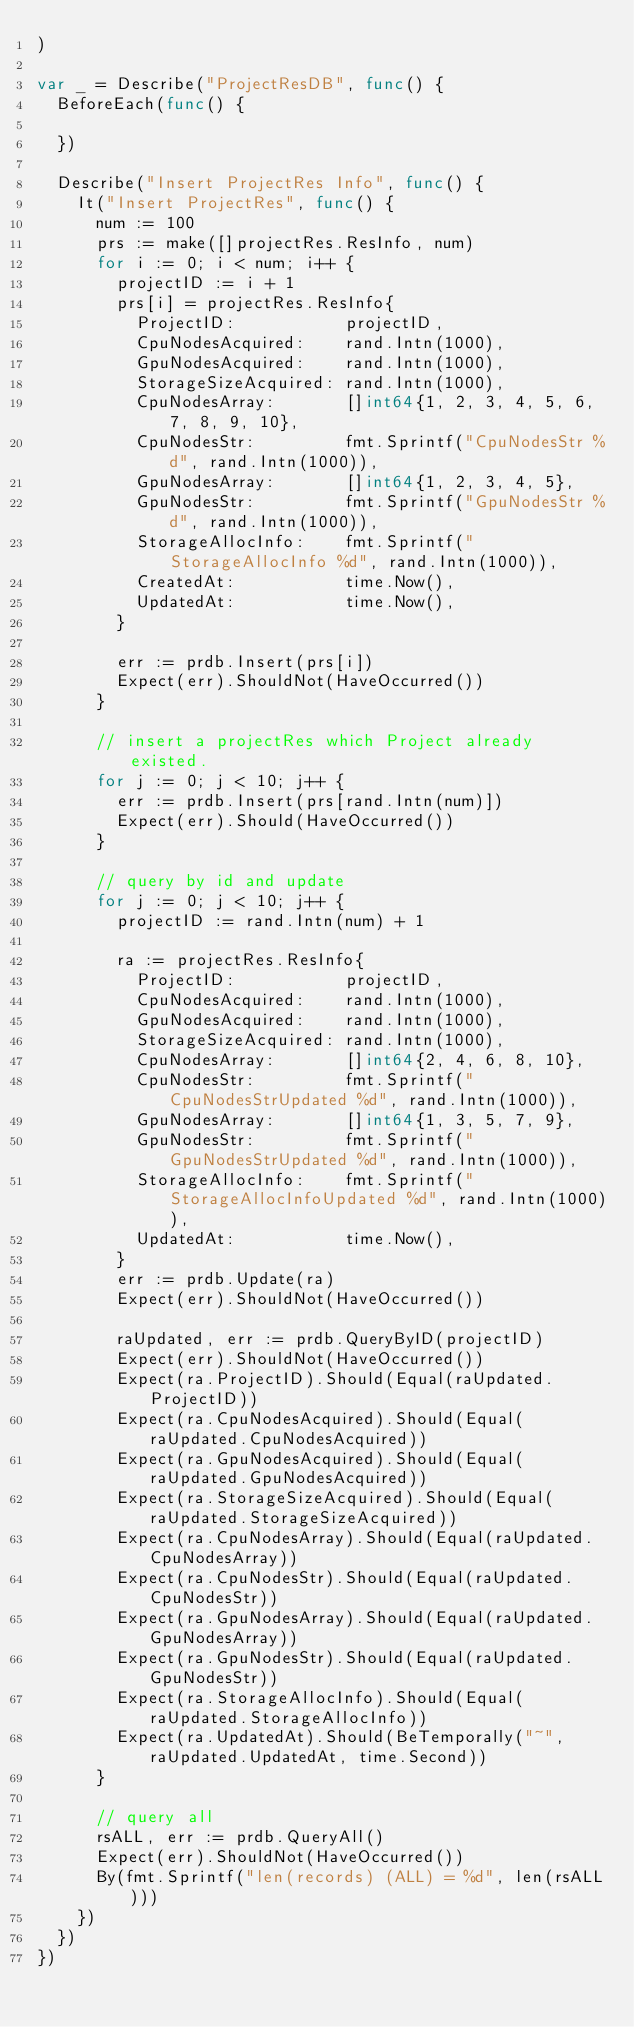<code> <loc_0><loc_0><loc_500><loc_500><_Go_>)

var _ = Describe("ProjectResDB", func() {
	BeforeEach(func() {

	})

	Describe("Insert ProjectRes Info", func() {
		It("Insert ProjectRes", func() {
			num := 100
			prs := make([]projectRes.ResInfo, num)
			for i := 0; i < num; i++ {
				projectID := i + 1
				prs[i] = projectRes.ResInfo{
					ProjectID:           projectID,
					CpuNodesAcquired:    rand.Intn(1000),
					GpuNodesAcquired:    rand.Intn(1000),
					StorageSizeAcquired: rand.Intn(1000),
					CpuNodesArray:       []int64{1, 2, 3, 4, 5, 6, 7, 8, 9, 10},
					CpuNodesStr:         fmt.Sprintf("CpuNodesStr %d", rand.Intn(1000)),
					GpuNodesArray:       []int64{1, 2, 3, 4, 5},
					GpuNodesStr:         fmt.Sprintf("GpuNodesStr %d", rand.Intn(1000)),
					StorageAllocInfo:    fmt.Sprintf("StorageAllocInfo %d", rand.Intn(1000)),
					CreatedAt:           time.Now(),
					UpdatedAt:           time.Now(),
				}

				err := prdb.Insert(prs[i])
				Expect(err).ShouldNot(HaveOccurred())
			}

			// insert a projectRes which Project already existed.
			for j := 0; j < 10; j++ {
				err := prdb.Insert(prs[rand.Intn(num)])
				Expect(err).Should(HaveOccurred())
			}

			// query by id and update
			for j := 0; j < 10; j++ {
				projectID := rand.Intn(num) + 1

				ra := projectRes.ResInfo{
					ProjectID:           projectID,
					CpuNodesAcquired:    rand.Intn(1000),
					GpuNodesAcquired:    rand.Intn(1000),
					StorageSizeAcquired: rand.Intn(1000),
					CpuNodesArray:       []int64{2, 4, 6, 8, 10},
					CpuNodesStr:         fmt.Sprintf("CpuNodesStrUpdated %d", rand.Intn(1000)),
					GpuNodesArray:       []int64{1, 3, 5, 7, 9},
					GpuNodesStr:         fmt.Sprintf("GpuNodesStrUpdated %d", rand.Intn(1000)),
					StorageAllocInfo:    fmt.Sprintf("StorageAllocInfoUpdated %d", rand.Intn(1000)),
					UpdatedAt:           time.Now(),
				}
				err := prdb.Update(ra)
				Expect(err).ShouldNot(HaveOccurred())

				raUpdated, err := prdb.QueryByID(projectID)
				Expect(err).ShouldNot(HaveOccurred())
				Expect(ra.ProjectID).Should(Equal(raUpdated.ProjectID))
				Expect(ra.CpuNodesAcquired).Should(Equal(raUpdated.CpuNodesAcquired))
				Expect(ra.GpuNodesAcquired).Should(Equal(raUpdated.GpuNodesAcquired))
				Expect(ra.StorageSizeAcquired).Should(Equal(raUpdated.StorageSizeAcquired))
				Expect(ra.CpuNodesArray).Should(Equal(raUpdated.CpuNodesArray))
				Expect(ra.CpuNodesStr).Should(Equal(raUpdated.CpuNodesStr))
				Expect(ra.GpuNodesArray).Should(Equal(raUpdated.GpuNodesArray))
				Expect(ra.GpuNodesStr).Should(Equal(raUpdated.GpuNodesStr))
				Expect(ra.StorageAllocInfo).Should(Equal(raUpdated.StorageAllocInfo))
				Expect(ra.UpdatedAt).Should(BeTemporally("~", raUpdated.UpdatedAt, time.Second))
			}

			// query all
			rsALL, err := prdb.QueryAll()
			Expect(err).ShouldNot(HaveOccurred())
			By(fmt.Sprintf("len(records) (ALL) = %d", len(rsALL)))
		})
	})
})
</code> 